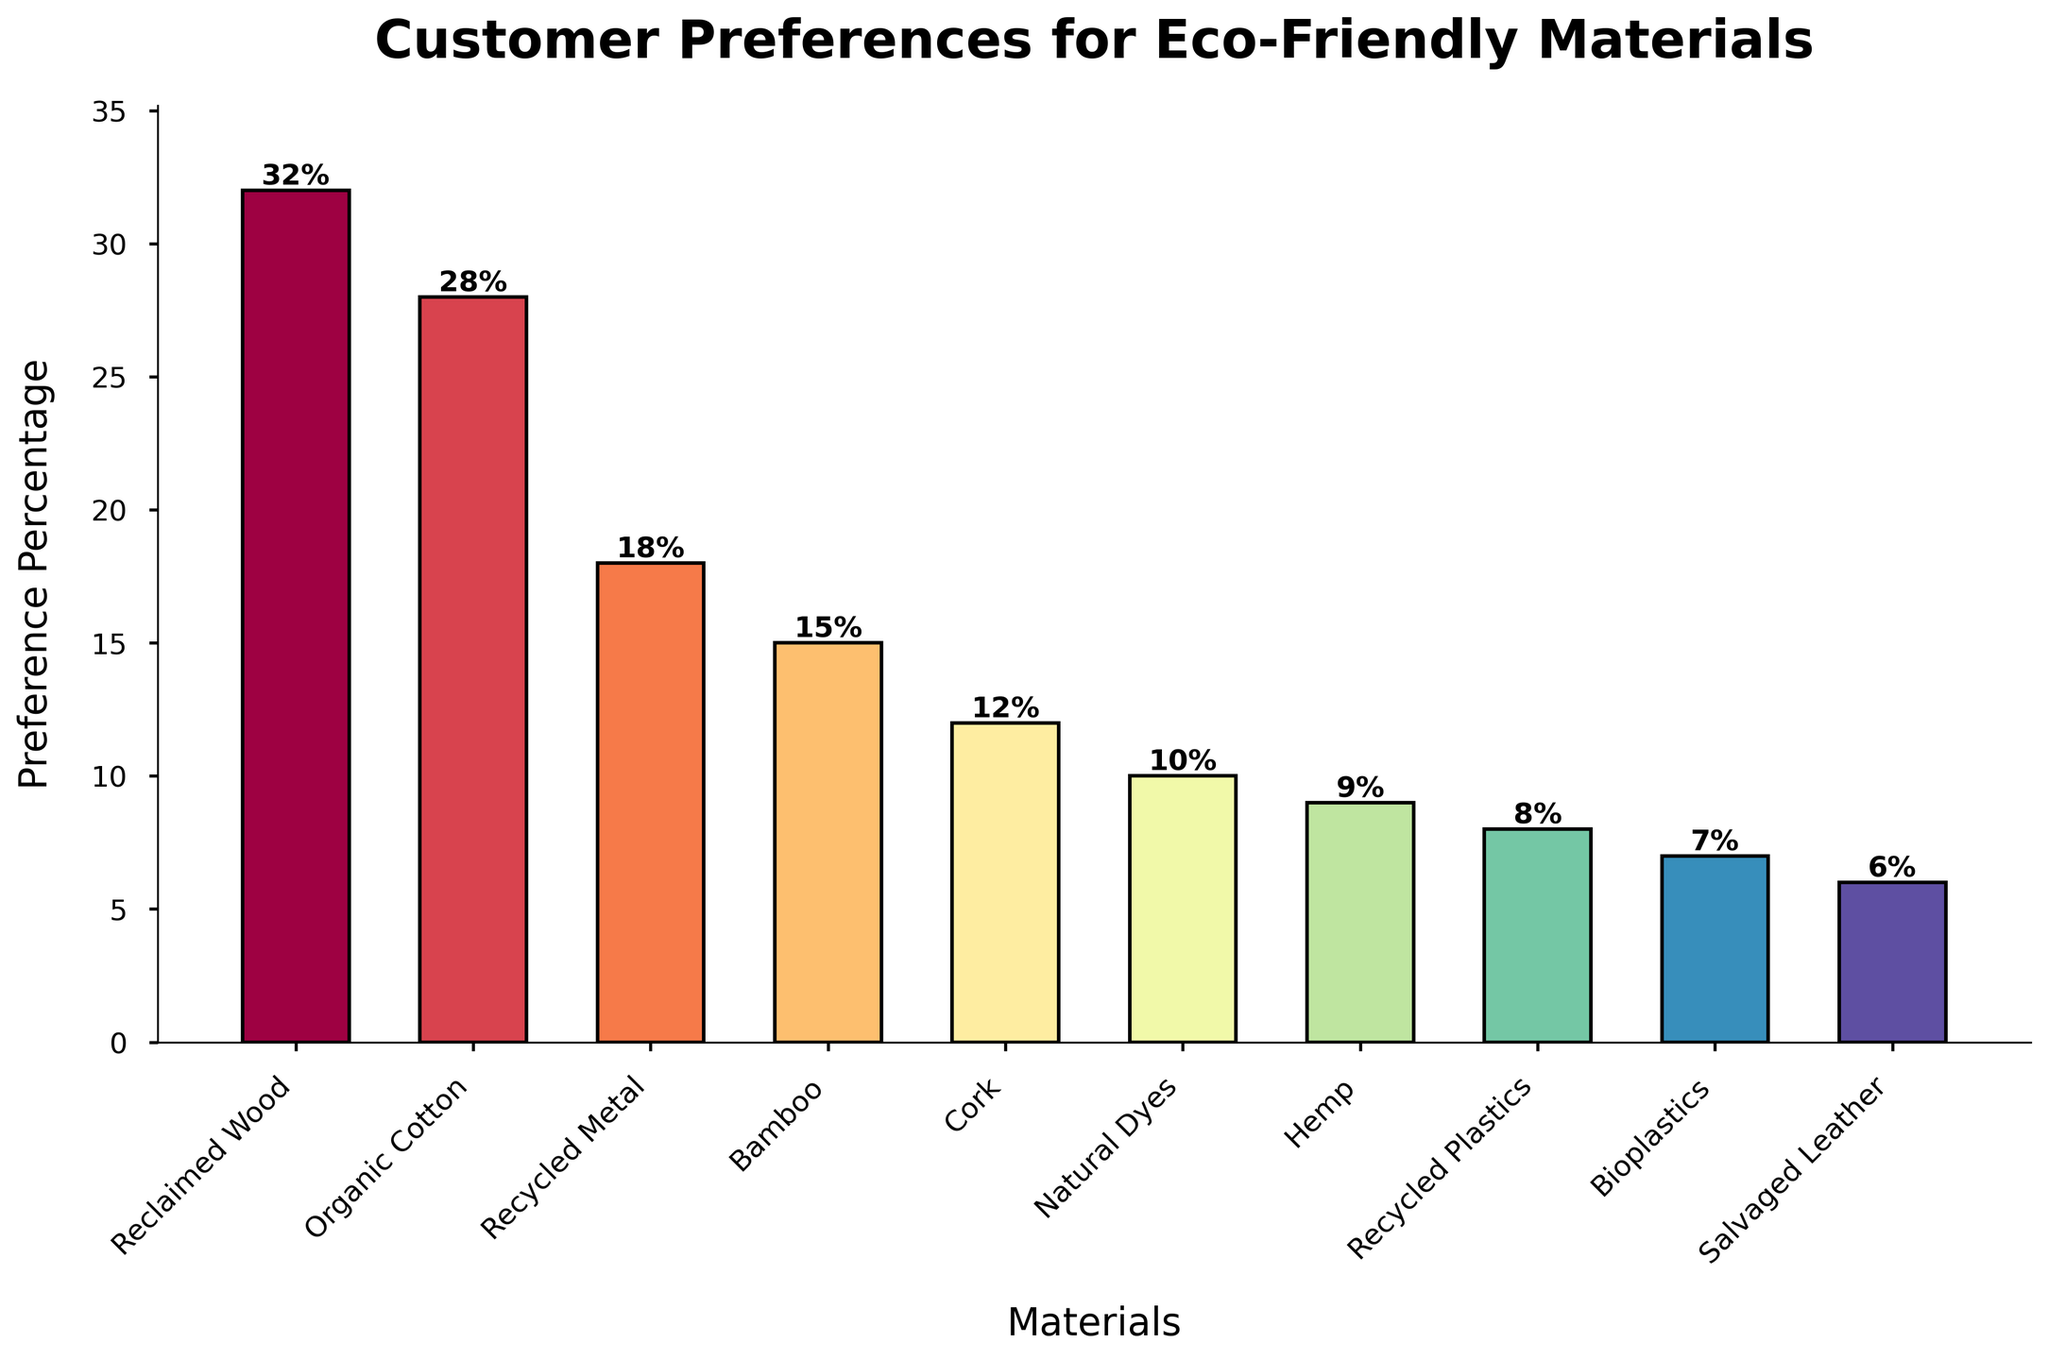What material has the highest preference percentage? The bar for Reclaimed Wood is the tallest with a percentage label of 32%.
Answer: Reclaimed Wood Which two materials have the lowest preference percentages? The bars for Salvaged Leather and Bioplastics are the shortest with percentage labels of 6% and 7%, respectively.
Answer: Salvaged Leather and Bioplastics What is the total preference percentage for Reclaimed Wood and Organic Cotton combined? Reclaimed Wood has a label of 32% and Organic Cotton has a label of 28%. Adding these together, 32% + 28% = 60%.
Answer: 60% Which material has a higher preference percentage, Bamboo or Recycled Metal? The bar for Recycled Metal is taller and is labeled 18%, while Bamboo is labeled 15%.
Answer: Recycled Metal How much higher is the preference percentage for Reclaimed Wood compared to Bamboo? Reclaimed Wood is labeled 32% and Bamboo is labeled 15%. The difference is 32% - 15% = 17%.
Answer: 17% What is the average preference percentage among all materials? Sum all percentages (32% + 28% + 18% + 15% + 12% + 10% + 9% + 8% + 7% + 6%) = 145%. There are 10 materials, so the average is 145% / 10 = 14.5%.
Answer: 14.5% Is the preference percentage for Reclaimed Wood more than the sum of the percentages for Hemp and Recycled Plastics? Reclaimed Wood is 32%. Hemp is 9% and Recycled Plastics is 8%. Sum of Hemp and Recycled Plastics is 9% + 8% = 17%. 32% is greater than 17%.
Answer: Yes Which material's preference percentage is closest to the average preference percentage? The average preference percentage is 14.5%. Bamboo at 15% is closest to this average.
Answer: Bamboo 